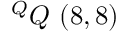<formula> <loc_0><loc_0><loc_500><loc_500>^ { Q } Q \ ( 8 , 8 )</formula> 